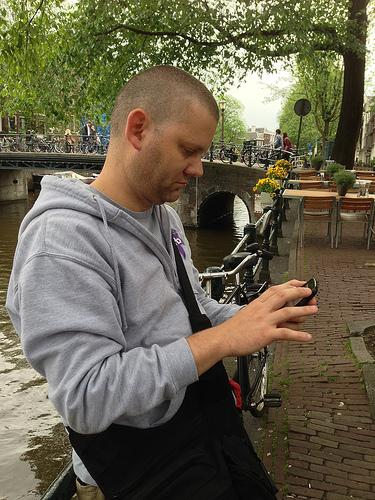Identify the type of clothing the man is wearing and his physical appearance. The man is wearing a grey hooded sweatshirt and has a shaved head with buzzed hair. Describe the emotions or feelings that the image might convey to the viewer. The image conveys a sense of everyday urban life, with people engaged in various activities like using a cell phone or riding a bike. Mention the type of seating arrangement present in the image and the material used for it. There are chairs with wooden backs and a brown wood dinner table. What type of electronic device is the man using, and what is its color? The man is using a small black cell phone. List down three distinct objects found on this bridge. Bikes, potted flowers, and a round sign on a pole. Count the number of different seating items visible in the image. At least 2 chairs and 1 dinner table. What kind of path is visible in the image and describe its condition? An uneven brick walkway with red bricks, and it appears old and worn out. Explain the type of bridge present in the image and mention one unique feature about it. The image shows a stone bridge over water with a distinctive arch over the water. What is the visual quality of the water in the image? Describe its color and appearance. The water appears murky and dirty with a brownish color. Can you briefly describe a mode of transportation present on the bridge? There are multiple bicycles parked or being ridden over the bridge. Can you look for a little girl in a pink dress playing near the tree with a teddy bear? This dress has white polka dots and ribbons on it. There is no mention of a little girl, a pink dress, or a teddy bear in the given image information. This instruction is misleading as it asks the user to find an object that doesn't exist and uses descriptive details to make the non-existent object seem specific. Could you spot the hot air balloon that is flying above the bridge? It's red and white striped and has a large company logo on the side. No, it's not mentioned in the image. Notice the colorful graffiti and street art on the wall behind the row of bicycles on the bridge. There is a unique blend of words and images that tell a story about the community there. There is no mention of graffiti or street art in the given image details. This instruction is misleading as it asks the user to search for a non-existent object while describing it in a way that paints a vivid picture of an attractive and culturally-relevant scene. Locate the big umbrella set up next to the chairs and table, it is blue and the family is enjoying their lunch underneath. The instruction is misleading because there is no mention of an umbrella or a family enjoying lunch in the given image information. This instruction is deceptive as it suggests a specific scene of enjoyment which is not present. 